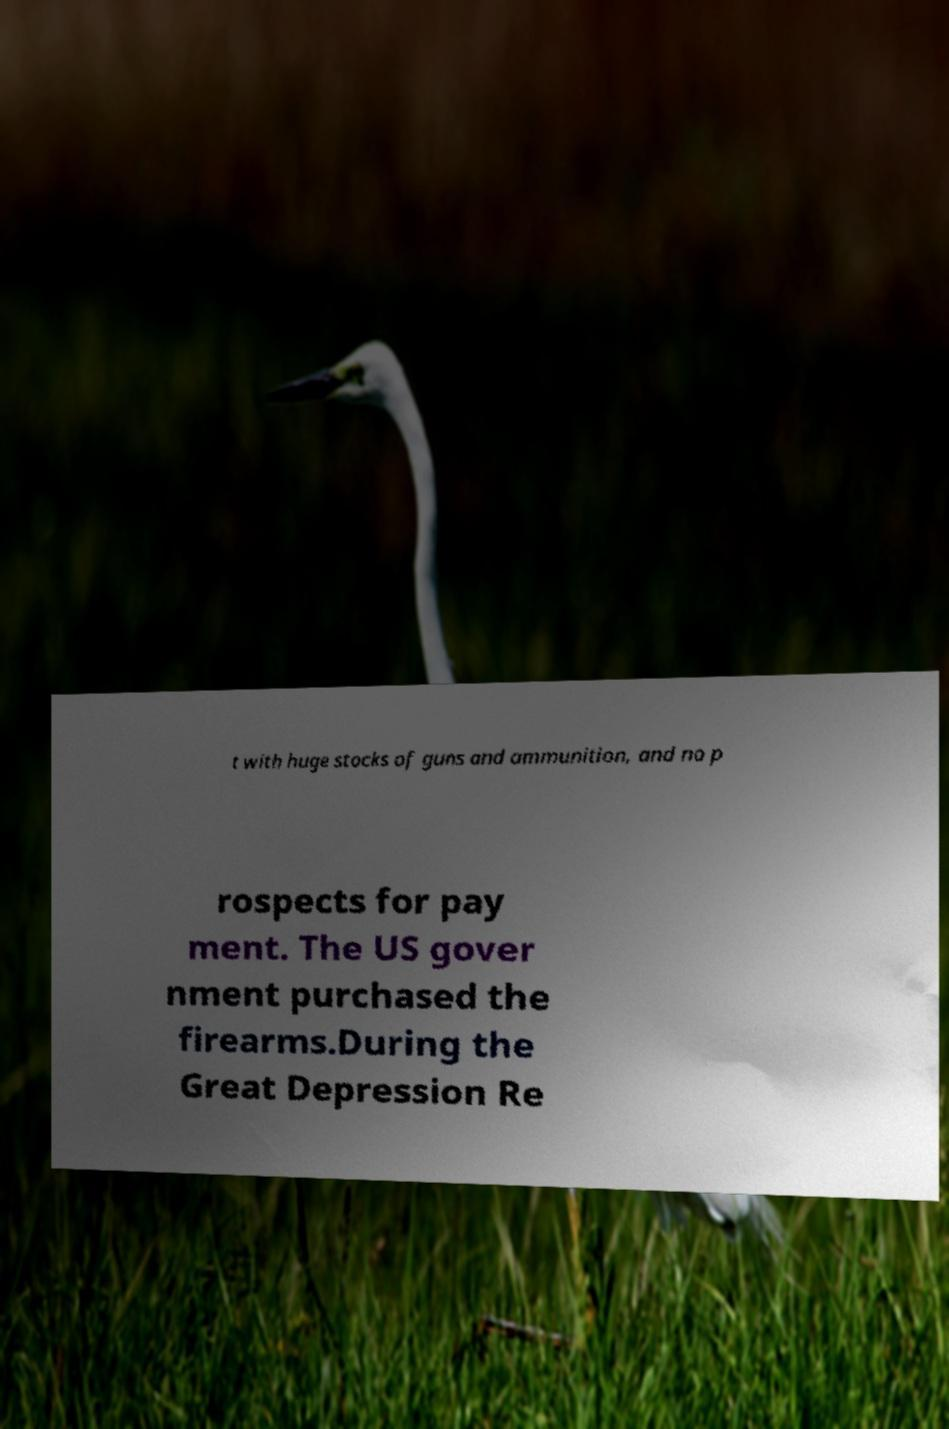For documentation purposes, I need the text within this image transcribed. Could you provide that? t with huge stocks of guns and ammunition, and no p rospects for pay ment. The US gover nment purchased the firearms.During the Great Depression Re 